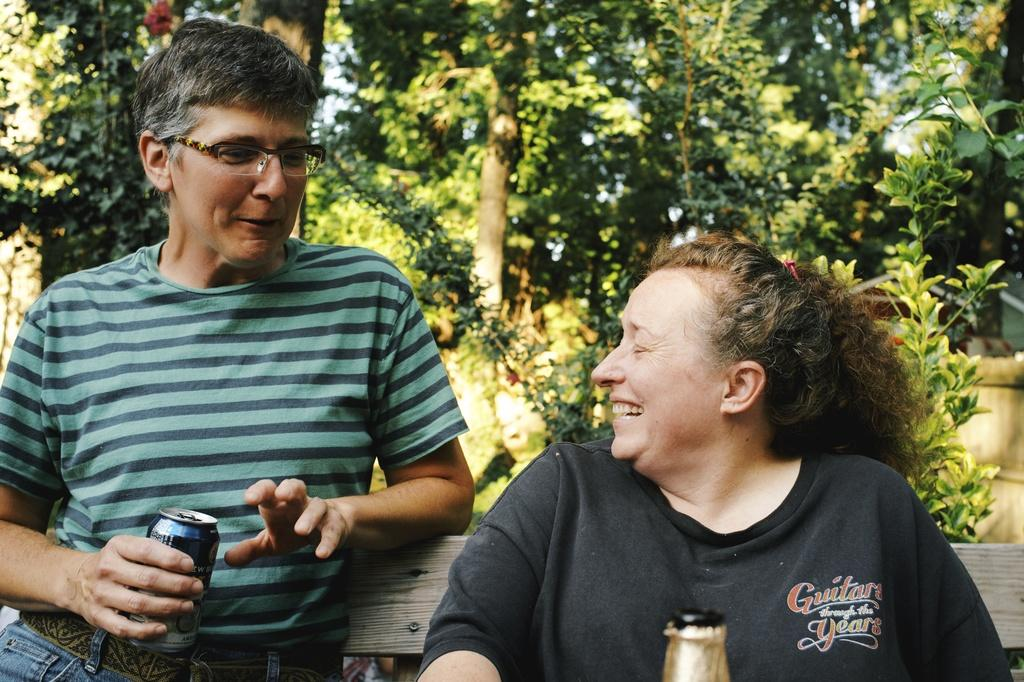How many people are present in the image? There are two people, a man and a woman, present in the image. What are the man and woman doing in the image? Both the man and woman are sitting on a bench. What is the man holding in his hand? The man is holding a drink can in his hand. What can be seen in the background of the image? There are trees visible in the background of the image. What object is located at the bottom of the image? There is a bottle at the bottom of the image. What type of authority does the man have over the woman's toes in the image? There is no mention of toes or any authority in the image; it simply shows a man and a woman sitting on a bench. 